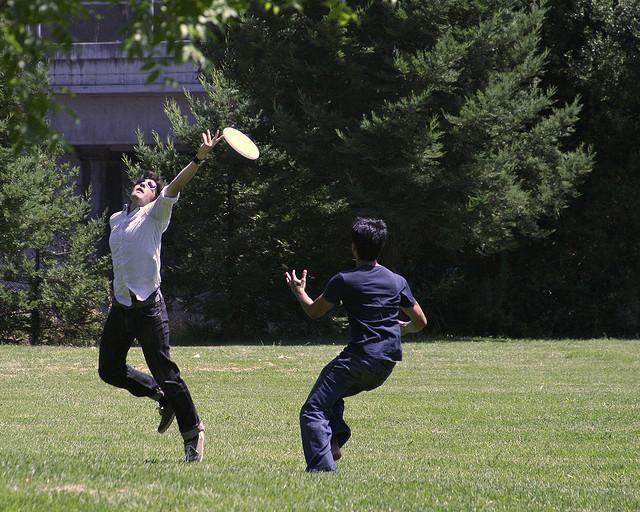The man in the white shirt is using what to touch the frisbee?
From the following four choices, select the correct answer to address the question.
Options: Thumb, wrist, fingernails, fingertips. Fingertips. 